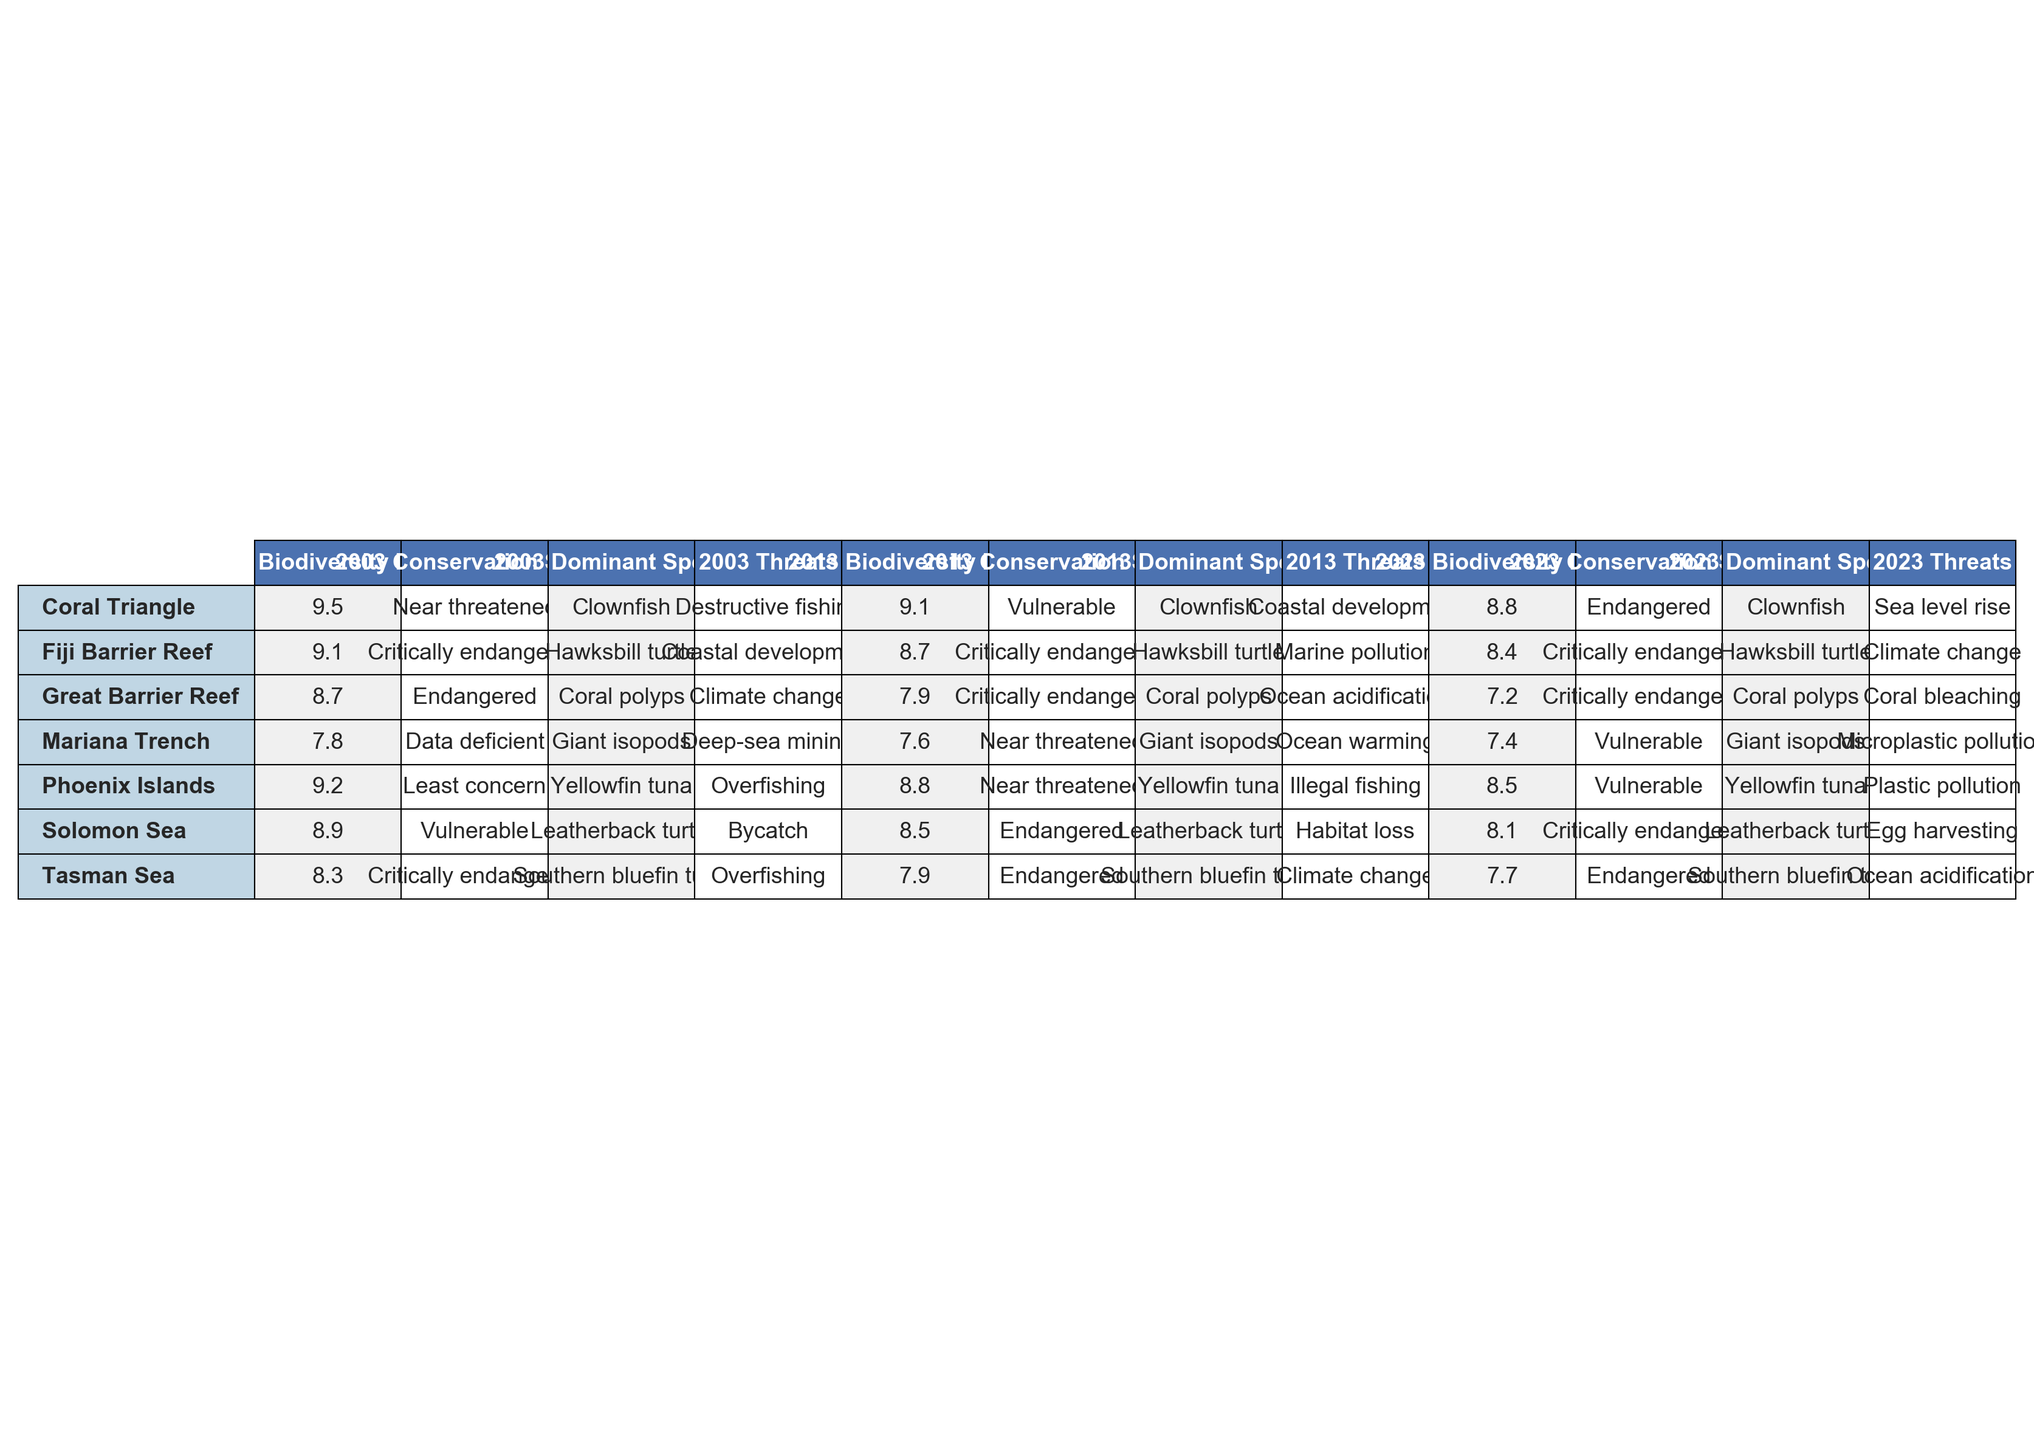What is the biodiversity index of the Great Barrier Reef in 2023? The table shows that the biodiversity index for the Great Barrier Reef in 2023 is listed under the '2023 Biodiversity Index' column. It states a value of 7.2.
Answer: 7.2 Which ecosystem had the highest biodiversity index in 2003? By looking at the '2003 Biodiversity Index' column for all ecosystems, the Coral Triangle has the highest value at 9.5.
Answer: Coral Triangle What threat is affecting the Phoenix Islands in 2023? The table indicates that the threat affecting the Phoenix Islands in 2023 is 'Plastic pollution', as shown in the corresponding '2023 Threats' column.
Answer: Plastic pollution Which ecosystem showed a decline in biodiversity index from 2003 to 2023? By comparing the '2003 Biodiversity Index' and '2023 Biodiversity Index' values across ecosystems, we see that the Great Barrier Reef, Phoenix Islands, Coral Triangle, Mariana Trench, Solomon Sea, Tasman Sea, and Fiji Barrier Reef all experienced declines. For example, the Great Barrier Reef went from 8.7 to 7.2.
Answer: Great Barrier Reef, Phoenix Islands, Coral Triangle, Mariana Trench, Solomon Sea, Tasman Sea, Fiji Barrier Reef What is the dominant species in the Solomon Sea in 2013? The table lists the 'Dominant Species' under the '2013 Dominant Species' column for the Solomon Sea, which is 'Leatherback turtle'.
Answer: Leatherback turtle How much did the biodiversity index of the Coral Triangle decrease over the last 20 years? The Coral Triangle had a biodiversity index of 9.5 in 2003 and 8.8 in 2023. The decrease is calculated as 9.5 - 8.8 = 0.7.
Answer: 0.7 Does the Tasman Sea have a conservation status of 'Endangered' in 2023? The conservation status for the Tasman Sea in 2023 is noted in the '2023 Conservation Status' column, which states 'Endangered'. Thus, the statement is true.
Answer: Yes What is the average biodiversity index of the Fiji Barrier Reef over the last 20 years? Collecting the biodiversity indices for the Fiji Barrier Reef in 2003 (9.1), 2013 (8.7), and 2023 (8.4), we compute the average as (9.1 + 8.7 + 8.4) / 3 = 8.733.
Answer: 8.7 Which ecosystem has shown the greatest overall decline in the biodiversity index between 2003 and 2023? The Great Barrier Reef went from 8.7 in 2003 to 7.2 in 2023, showing a decline of 1.5. The Coral Triangle was closer at a decline of 0.7, so the comparison across all ecosystems reveals that the Great Barrier Reef had the greatest decline.
Answer: Great Barrier Reef What are the threats affecting the marine biodiversity in the Mariana Trench over the years? The table outlines various threats for the Mariana Trench: 'Deep-sea mining' in 2003, 'Ocean warming' in 2013, and 'Microplastic pollution' in 2023. This shows an evolving threat landscape.
Answer: Deep-sea mining, Ocean warming, Microplastic pollution 